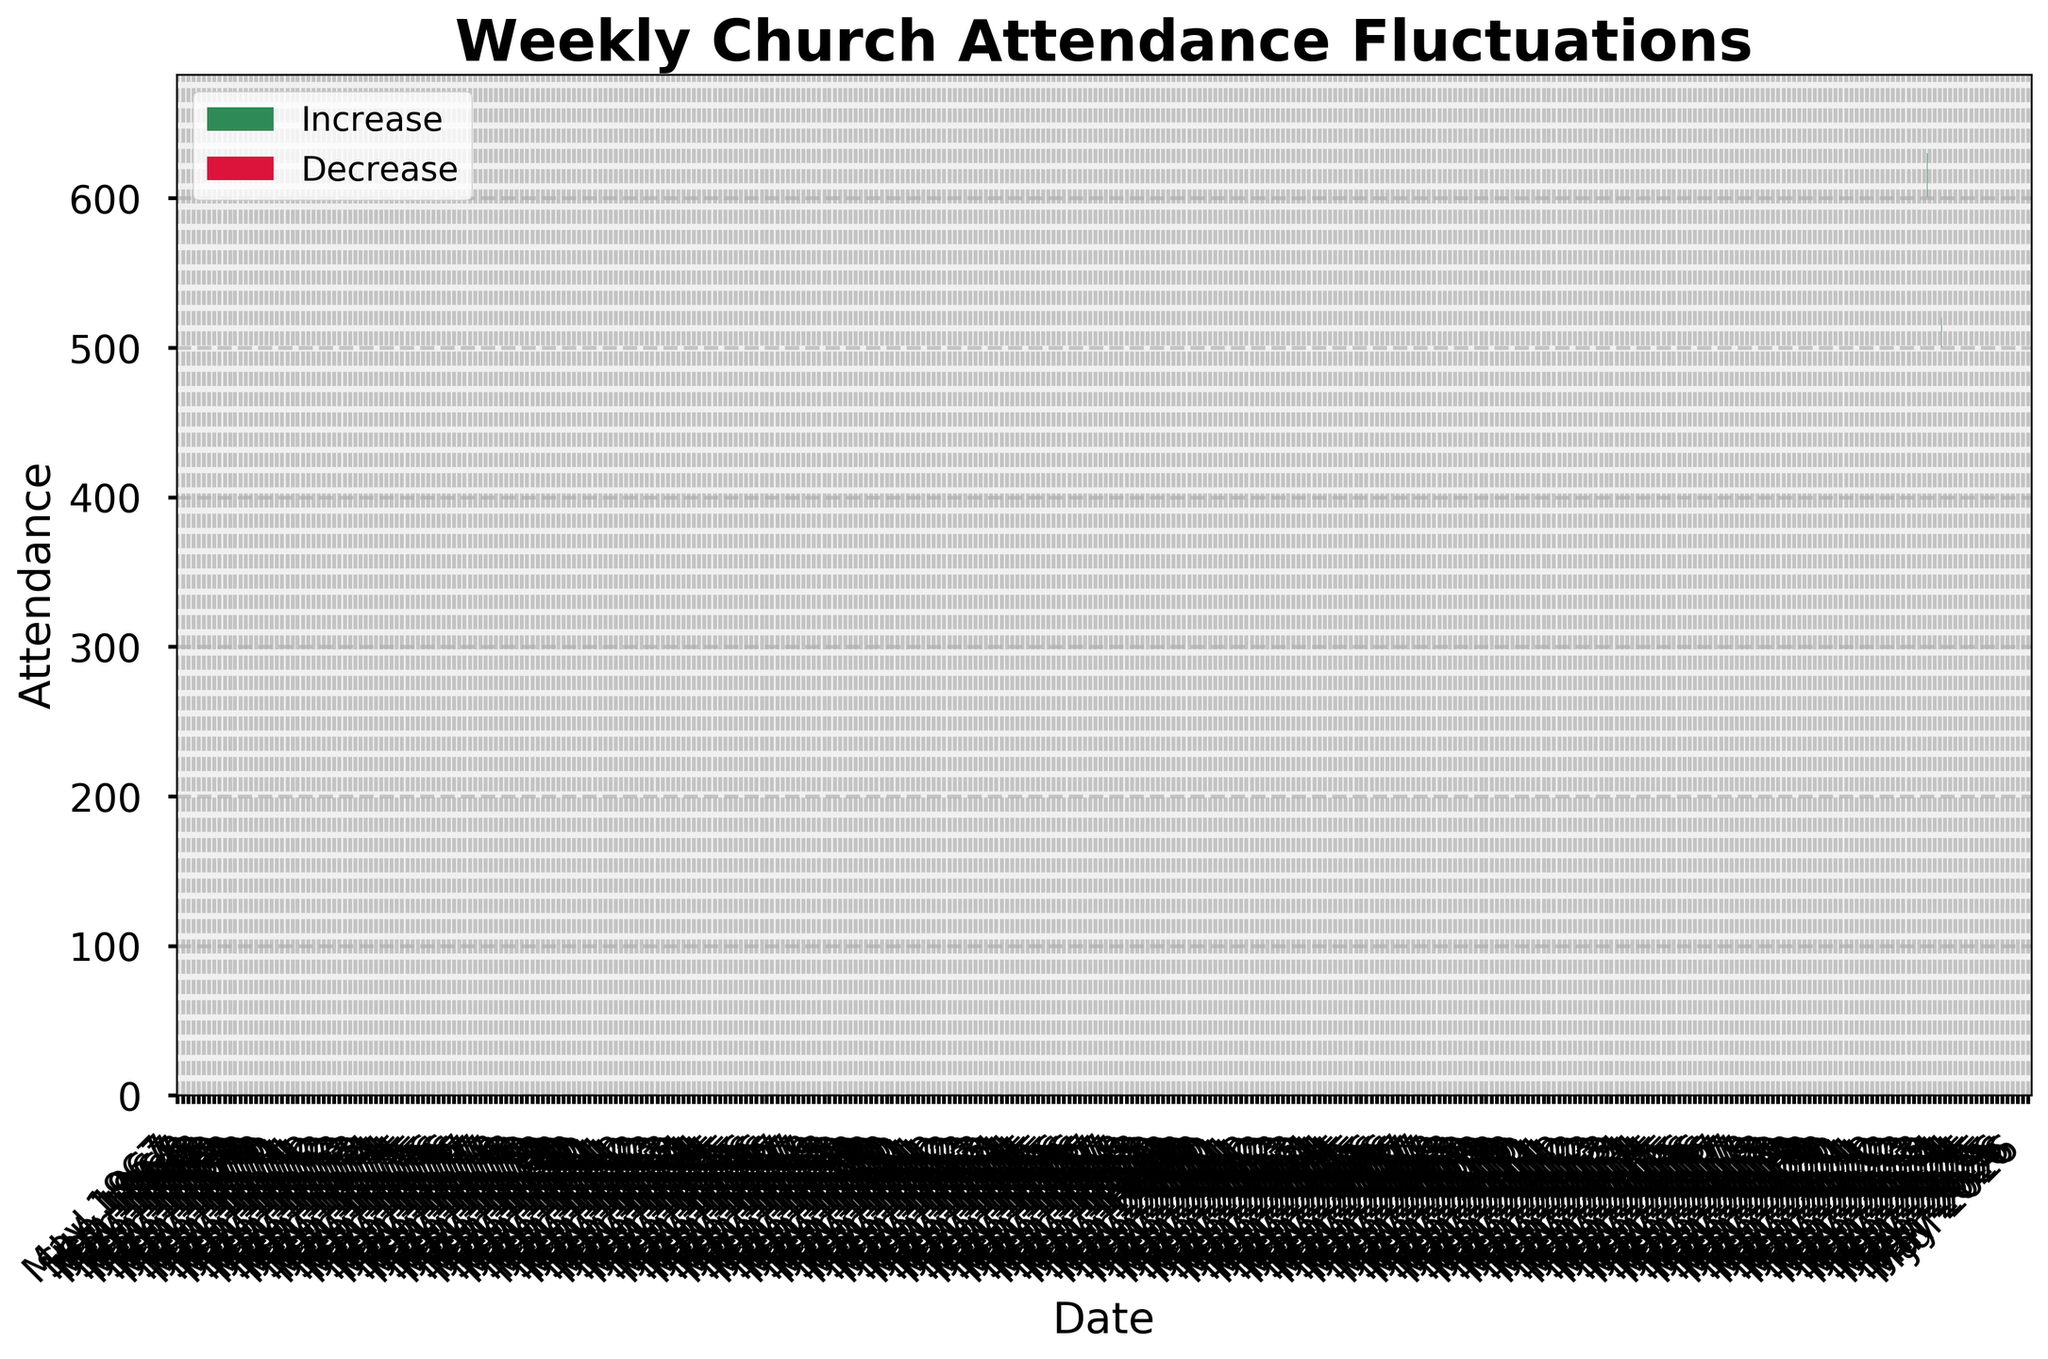what is the title of the figure? The title of the figure is displayed at the top, typically in bold text.
Answer: Weekly Church Attendance Fluctuations How many times did the attendance increase compared to the previous week? Visualizing the OHLC bars, count instances where the closing attendance value is higher than the opening attendance value. These instances will be in green color ("Increase").
Answer: 8 Which month saw the highest weekly attendance? By looking at the peaks of the high points for each month, we identify the highest peak, which occurs in April 2023.
Answer: April In which month was the lowest attendance recorded, and how low was it? Find the lowest attendance by examining the 'Low' points of each bar and determine that July shows the minimum low point of 460.
Answer: July, 460 What does the x-axis represent in this chart? By examining the labeling of the x-axis, it usually represents dates or time periods.
Answer: Date Compare the attendance between February and March. Which was higher? By comparing the 'Close' values in the ethos of February and March, it becomes clear that March has a higher attendance (560 vs. 530).
Answer: March How many months show a decrease in weekly attendance? Observing the OHLC bars in red ("Decrease") and counting these events gives us the number of months.
Answer: 4 What is the trend of church attendance in the last four months of the year (Sept to Dec)? Analyzing the OHLC pattern from September to December, examining the 'Close' values shows an upward trend.
Answer: Increasing Which season had the most fluctuations in church attendance? Determine which season has the widest range between high and low points; in this case, Spring (March to June) shows significant variations.
Answer: Spring What are the high and low attendance points in the summer months (June to August)? Looking at June, July, and August high and low points, we get highs of 560, 520, and 510 respectively, and lows of 500, 460, and 450 respectively.
Answer: Highs: 560, 520, 510; Lows: 500, 460, 450 